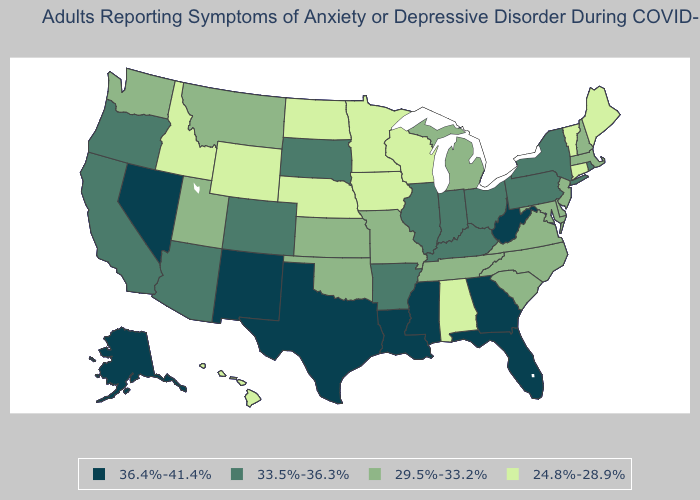Does New Hampshire have the lowest value in the Northeast?
Quick response, please. No. Does Louisiana have the highest value in the USA?
Give a very brief answer. Yes. Which states hav the highest value in the Northeast?
Be succinct. New York, Pennsylvania, Rhode Island. What is the value of Colorado?
Answer briefly. 33.5%-36.3%. What is the value of Kentucky?
Give a very brief answer. 33.5%-36.3%. Does the map have missing data?
Answer briefly. No. Among the states that border South Dakota , which have the lowest value?
Concise answer only. Iowa, Minnesota, Nebraska, North Dakota, Wyoming. Name the states that have a value in the range 33.5%-36.3%?
Be succinct. Arizona, Arkansas, California, Colorado, Illinois, Indiana, Kentucky, New York, Ohio, Oregon, Pennsylvania, Rhode Island, South Dakota. Which states have the highest value in the USA?
Write a very short answer. Alaska, Florida, Georgia, Louisiana, Mississippi, Nevada, New Mexico, Texas, West Virginia. Among the states that border New Hampshire , does Vermont have the highest value?
Short answer required. No. What is the lowest value in states that border California?
Be succinct. 33.5%-36.3%. Does New Jersey have the lowest value in the USA?
Keep it brief. No. Among the states that border New York , does Connecticut have the highest value?
Be succinct. No. What is the value of Texas?
Concise answer only. 36.4%-41.4%. 